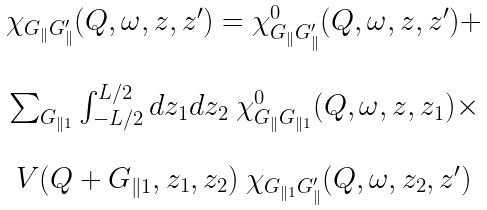Convert formula to latex. <formula><loc_0><loc_0><loc_500><loc_500>\begin{array} { c } \chi _ { G _ { \| } G _ { \| } ^ { \prime } } ( Q , \omega , z , z ^ { \prime } ) = \chi _ { G _ { \| } G _ { \| } ^ { \prime } } ^ { 0 } ( Q , \omega , z , z ^ { \prime } ) + \\ \\ \sum _ { G _ { \| 1 } } \int ^ { L / 2 } _ { - L / 2 } d z _ { 1 } d z _ { 2 } \ \chi _ { G _ { \| } G _ { \| 1 } } ^ { 0 } ( Q , \omega , z , z _ { 1 } ) \times \\ \\ V ( Q + G _ { \| 1 } , z _ { 1 } , z _ { 2 } ) \ \chi _ { G _ { \| 1 } G _ { \| } ^ { \prime } } ( Q , \omega , z _ { 2 } , z ^ { \prime } ) \end{array}</formula> 